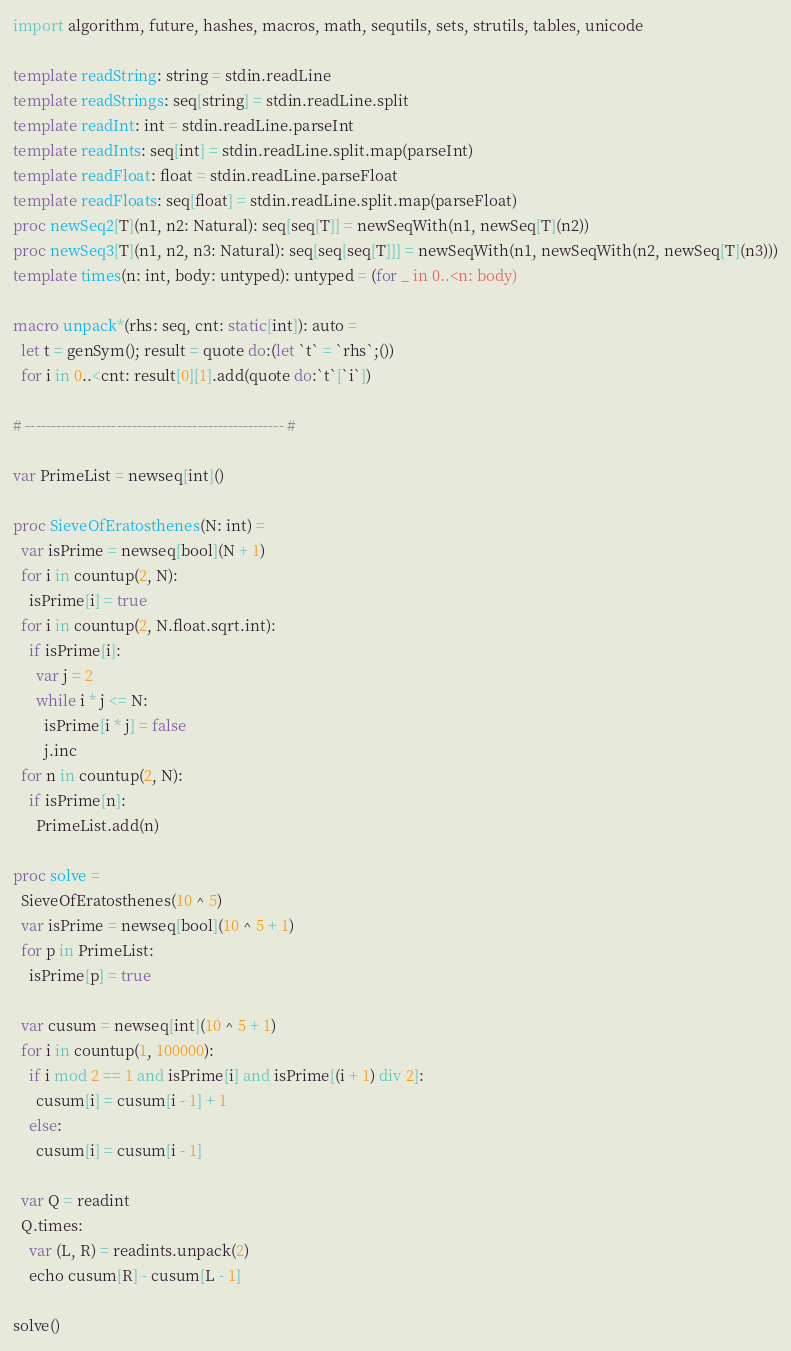Convert code to text. <code><loc_0><loc_0><loc_500><loc_500><_Nim_>import algorithm, future, hashes, macros, math, sequtils, sets, strutils, tables, unicode

template readString: string = stdin.readLine
template readStrings: seq[string] = stdin.readLine.split
template readInt: int = stdin.readLine.parseInt
template readInts: seq[int] = stdin.readLine.split.map(parseInt)
template readFloat: float = stdin.readLine.parseFloat
template readFloats: seq[float] = stdin.readLine.split.map(parseFloat)
proc newSeq2[T](n1, n2: Natural): seq[seq[T]] = newSeqWith(n1, newSeq[T](n2))
proc newSeq3[T](n1, n2, n3: Natural): seq[seq[seq[T]]] = newSeqWith(n1, newSeqWith(n2, newSeq[T](n3)))
template times(n: int, body: untyped): untyped = (for _ in 0..<n: body)

macro unpack*(rhs: seq, cnt: static[int]): auto =
  let t = genSym(); result = quote do:(let `t` = `rhs`;())
  for i in 0..<cnt: result[0][1].add(quote do:`t`[`i`])

# --------------------------------------------------- #

var PrimeList = newseq[int]()

proc SieveOfEratosthenes(N: int) =
  var isPrime = newseq[bool](N + 1)
  for i in countup(2, N):
    isPrime[i] = true
  for i in countup(2, N.float.sqrt.int):
    if isPrime[i]:
      var j = 2
      while i * j <= N:
        isPrime[i * j] = false
        j.inc
  for n in countup(2, N):
    if isPrime[n]:
      PrimeList.add(n)

proc solve =
  SieveOfEratosthenes(10 ^ 5)
  var isPrime = newseq[bool](10 ^ 5 + 1)
  for p in PrimeList:
    isPrime[p] = true

  var cusum = newseq[int](10 ^ 5 + 1)
  for i in countup(1, 100000):
    if i mod 2 == 1 and isPrime[i] and isPrime[(i + 1) div 2]:
      cusum[i] = cusum[i - 1] + 1
    else:
      cusum[i] = cusum[i - 1]

  var Q = readint
  Q.times:
    var (L, R) = readints.unpack(2)
    echo cusum[R] - cusum[L - 1]

solve()</code> 